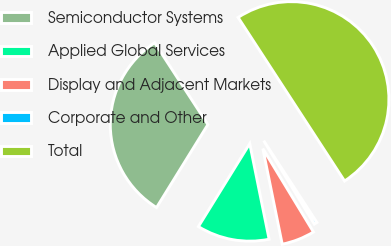Convert chart. <chart><loc_0><loc_0><loc_500><loc_500><pie_chart><fcel>Semiconductor Systems<fcel>Applied Global Services<fcel>Display and Adjacent Markets<fcel>Corporate and Other<fcel>Total<nl><fcel>32.0%<fcel>12.0%<fcel>5.5%<fcel>0.5%<fcel>50.0%<nl></chart> 